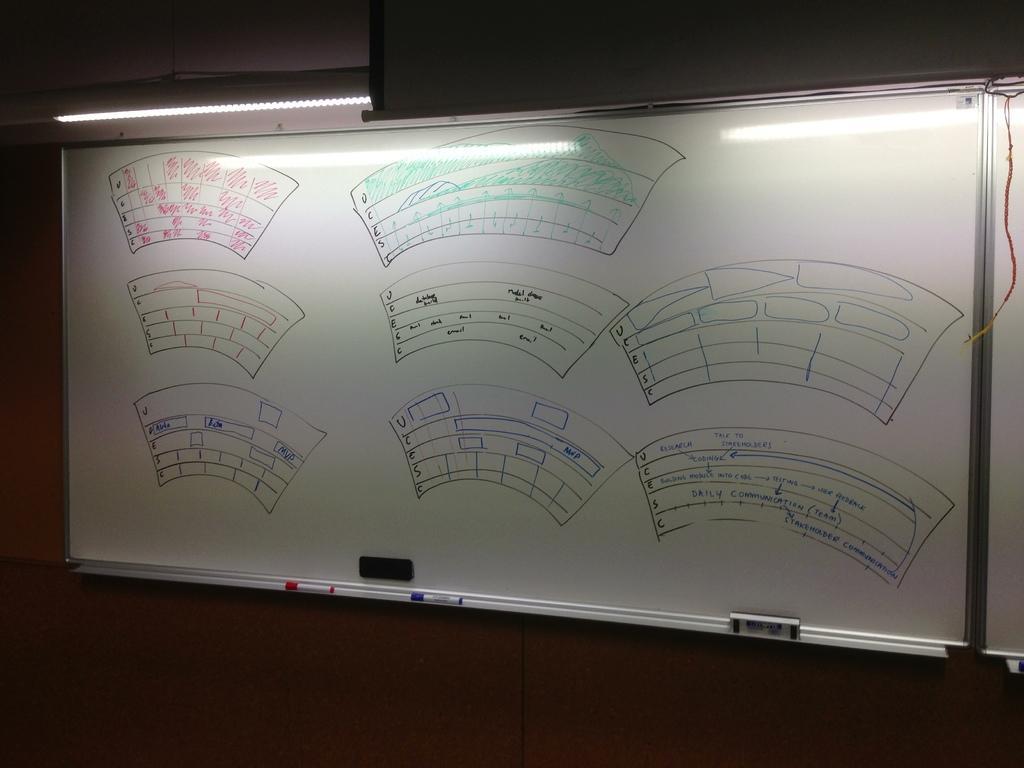Please provide a concise description of this image. In the foreground I can see a white board, light and a wall. This image is taken may be in a hall. 